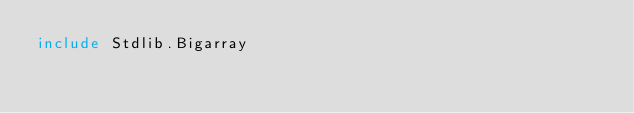Convert code to text. <code><loc_0><loc_0><loc_500><loc_500><_OCaml_>include Stdlib.Bigarray</code> 